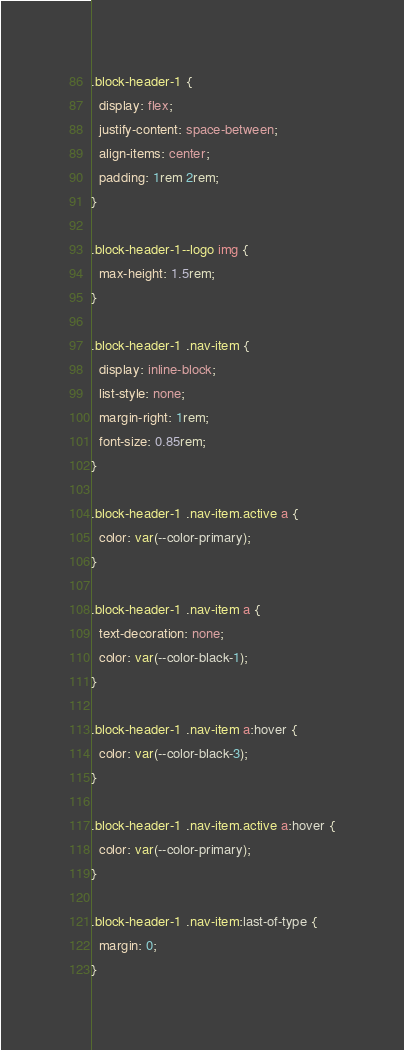<code> <loc_0><loc_0><loc_500><loc_500><_CSS_>.block-header-1 {
  display: flex;
  justify-content: space-between;
  align-items: center;
  padding: 1rem 2rem;
}

.block-header-1--logo img {
  max-height: 1.5rem;
}

.block-header-1 .nav-item {
  display: inline-block;
  list-style: none;
  margin-right: 1rem;
  font-size: 0.85rem;
}

.block-header-1 .nav-item.active a {
  color: var(--color-primary);
}

.block-header-1 .nav-item a {
  text-decoration: none;
  color: var(--color-black-1);
}

.block-header-1 .nav-item a:hover {
  color: var(--color-black-3);
}

.block-header-1 .nav-item.active a:hover {
  color: var(--color-primary);
}

.block-header-1 .nav-item:last-of-type {
  margin: 0;
}</code> 